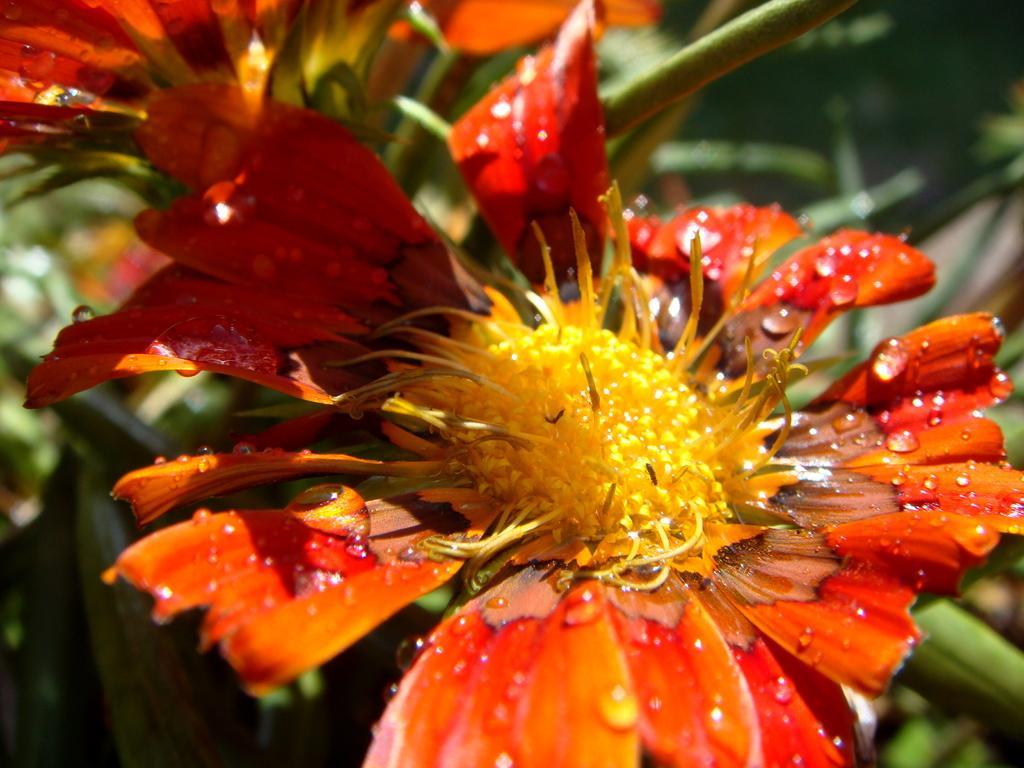Can you describe this image briefly? In this image I can see red color flowers. 